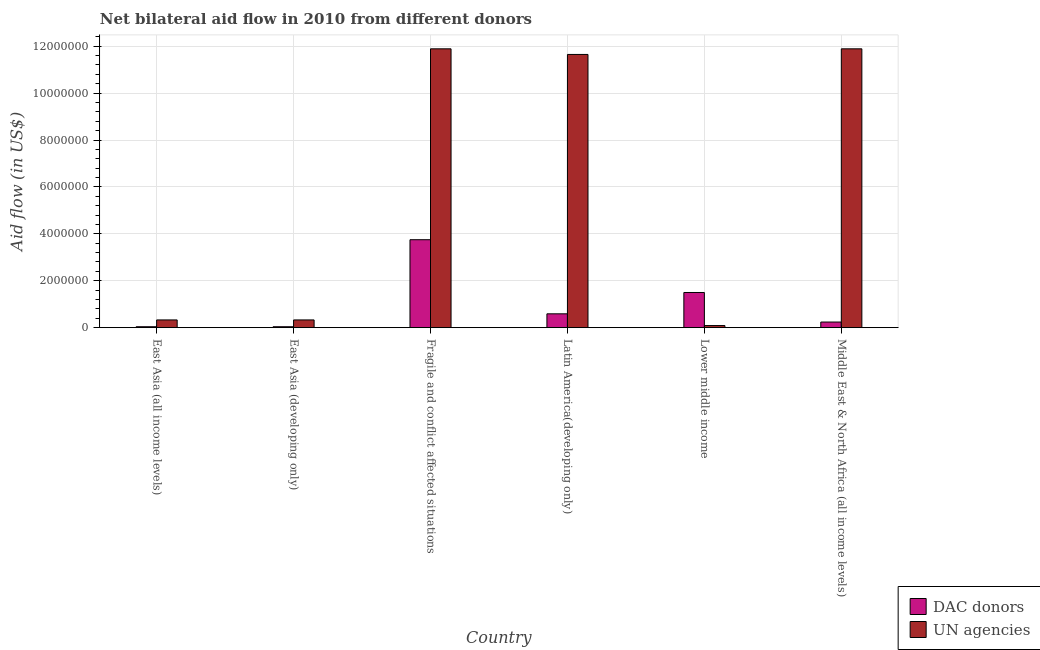Are the number of bars per tick equal to the number of legend labels?
Make the answer very short. Yes. Are the number of bars on each tick of the X-axis equal?
Ensure brevity in your answer.  Yes. What is the label of the 6th group of bars from the left?
Make the answer very short. Middle East & North Africa (all income levels). What is the aid flow from un agencies in Middle East & North Africa (all income levels)?
Your answer should be compact. 1.19e+07. Across all countries, what is the maximum aid flow from un agencies?
Your response must be concise. 1.19e+07. Across all countries, what is the minimum aid flow from dac donors?
Provide a short and direct response. 4.00e+04. In which country was the aid flow from un agencies maximum?
Provide a succinct answer. Fragile and conflict affected situations. In which country was the aid flow from dac donors minimum?
Your answer should be compact. East Asia (all income levels). What is the total aid flow from dac donors in the graph?
Your answer should be very brief. 6.16e+06. What is the difference between the aid flow from dac donors in East Asia (all income levels) and that in Latin America(developing only)?
Offer a very short reply. -5.50e+05. What is the difference between the aid flow from un agencies in Lower middle income and the aid flow from dac donors in East Asia (all income levels)?
Provide a short and direct response. 5.00e+04. What is the average aid flow from dac donors per country?
Your answer should be very brief. 1.03e+06. What is the difference between the aid flow from dac donors and aid flow from un agencies in East Asia (developing only)?
Keep it short and to the point. -2.90e+05. What is the ratio of the aid flow from dac donors in East Asia (developing only) to that in Latin America(developing only)?
Your response must be concise. 0.07. What is the difference between the highest and the second highest aid flow from dac donors?
Give a very brief answer. 2.25e+06. What is the difference between the highest and the lowest aid flow from dac donors?
Offer a very short reply. 3.71e+06. In how many countries, is the aid flow from un agencies greater than the average aid flow from un agencies taken over all countries?
Offer a terse response. 3. Is the sum of the aid flow from dac donors in Latin America(developing only) and Lower middle income greater than the maximum aid flow from un agencies across all countries?
Ensure brevity in your answer.  No. What does the 1st bar from the left in Fragile and conflict affected situations represents?
Keep it short and to the point. DAC donors. What does the 2nd bar from the right in Latin America(developing only) represents?
Offer a terse response. DAC donors. Are all the bars in the graph horizontal?
Offer a very short reply. No. How many countries are there in the graph?
Your response must be concise. 6. Does the graph contain any zero values?
Provide a short and direct response. No. Where does the legend appear in the graph?
Your answer should be compact. Bottom right. How many legend labels are there?
Your answer should be compact. 2. How are the legend labels stacked?
Your response must be concise. Vertical. What is the title of the graph?
Your answer should be very brief. Net bilateral aid flow in 2010 from different donors. What is the label or title of the Y-axis?
Your answer should be compact. Aid flow (in US$). What is the Aid flow (in US$) of DAC donors in Fragile and conflict affected situations?
Make the answer very short. 3.75e+06. What is the Aid flow (in US$) in UN agencies in Fragile and conflict affected situations?
Offer a very short reply. 1.19e+07. What is the Aid flow (in US$) of DAC donors in Latin America(developing only)?
Give a very brief answer. 5.90e+05. What is the Aid flow (in US$) in UN agencies in Latin America(developing only)?
Your answer should be very brief. 1.16e+07. What is the Aid flow (in US$) of DAC donors in Lower middle income?
Your answer should be very brief. 1.50e+06. What is the Aid flow (in US$) of UN agencies in Lower middle income?
Your answer should be compact. 9.00e+04. What is the Aid flow (in US$) of UN agencies in Middle East & North Africa (all income levels)?
Offer a very short reply. 1.19e+07. Across all countries, what is the maximum Aid flow (in US$) in DAC donors?
Give a very brief answer. 3.75e+06. Across all countries, what is the maximum Aid flow (in US$) of UN agencies?
Your answer should be compact. 1.19e+07. Across all countries, what is the minimum Aid flow (in US$) in UN agencies?
Make the answer very short. 9.00e+04. What is the total Aid flow (in US$) of DAC donors in the graph?
Provide a short and direct response. 6.16e+06. What is the total Aid flow (in US$) in UN agencies in the graph?
Offer a terse response. 3.62e+07. What is the difference between the Aid flow (in US$) in DAC donors in East Asia (all income levels) and that in East Asia (developing only)?
Make the answer very short. 0. What is the difference between the Aid flow (in US$) of UN agencies in East Asia (all income levels) and that in East Asia (developing only)?
Offer a terse response. 0. What is the difference between the Aid flow (in US$) of DAC donors in East Asia (all income levels) and that in Fragile and conflict affected situations?
Provide a short and direct response. -3.71e+06. What is the difference between the Aid flow (in US$) of UN agencies in East Asia (all income levels) and that in Fragile and conflict affected situations?
Keep it short and to the point. -1.16e+07. What is the difference between the Aid flow (in US$) in DAC donors in East Asia (all income levels) and that in Latin America(developing only)?
Keep it short and to the point. -5.50e+05. What is the difference between the Aid flow (in US$) of UN agencies in East Asia (all income levels) and that in Latin America(developing only)?
Make the answer very short. -1.13e+07. What is the difference between the Aid flow (in US$) in DAC donors in East Asia (all income levels) and that in Lower middle income?
Provide a succinct answer. -1.46e+06. What is the difference between the Aid flow (in US$) of DAC donors in East Asia (all income levels) and that in Middle East & North Africa (all income levels)?
Offer a terse response. -2.00e+05. What is the difference between the Aid flow (in US$) in UN agencies in East Asia (all income levels) and that in Middle East & North Africa (all income levels)?
Provide a succinct answer. -1.16e+07. What is the difference between the Aid flow (in US$) of DAC donors in East Asia (developing only) and that in Fragile and conflict affected situations?
Keep it short and to the point. -3.71e+06. What is the difference between the Aid flow (in US$) in UN agencies in East Asia (developing only) and that in Fragile and conflict affected situations?
Your response must be concise. -1.16e+07. What is the difference between the Aid flow (in US$) of DAC donors in East Asia (developing only) and that in Latin America(developing only)?
Make the answer very short. -5.50e+05. What is the difference between the Aid flow (in US$) in UN agencies in East Asia (developing only) and that in Latin America(developing only)?
Make the answer very short. -1.13e+07. What is the difference between the Aid flow (in US$) in DAC donors in East Asia (developing only) and that in Lower middle income?
Your response must be concise. -1.46e+06. What is the difference between the Aid flow (in US$) of UN agencies in East Asia (developing only) and that in Middle East & North Africa (all income levels)?
Provide a succinct answer. -1.16e+07. What is the difference between the Aid flow (in US$) of DAC donors in Fragile and conflict affected situations and that in Latin America(developing only)?
Keep it short and to the point. 3.16e+06. What is the difference between the Aid flow (in US$) in DAC donors in Fragile and conflict affected situations and that in Lower middle income?
Offer a terse response. 2.25e+06. What is the difference between the Aid flow (in US$) of UN agencies in Fragile and conflict affected situations and that in Lower middle income?
Make the answer very short. 1.18e+07. What is the difference between the Aid flow (in US$) of DAC donors in Fragile and conflict affected situations and that in Middle East & North Africa (all income levels)?
Your answer should be compact. 3.51e+06. What is the difference between the Aid flow (in US$) of UN agencies in Fragile and conflict affected situations and that in Middle East & North Africa (all income levels)?
Ensure brevity in your answer.  0. What is the difference between the Aid flow (in US$) in DAC donors in Latin America(developing only) and that in Lower middle income?
Provide a short and direct response. -9.10e+05. What is the difference between the Aid flow (in US$) in UN agencies in Latin America(developing only) and that in Lower middle income?
Make the answer very short. 1.16e+07. What is the difference between the Aid flow (in US$) in DAC donors in Lower middle income and that in Middle East & North Africa (all income levels)?
Keep it short and to the point. 1.26e+06. What is the difference between the Aid flow (in US$) in UN agencies in Lower middle income and that in Middle East & North Africa (all income levels)?
Give a very brief answer. -1.18e+07. What is the difference between the Aid flow (in US$) of DAC donors in East Asia (all income levels) and the Aid flow (in US$) of UN agencies in Fragile and conflict affected situations?
Make the answer very short. -1.18e+07. What is the difference between the Aid flow (in US$) of DAC donors in East Asia (all income levels) and the Aid flow (in US$) of UN agencies in Latin America(developing only)?
Offer a terse response. -1.16e+07. What is the difference between the Aid flow (in US$) of DAC donors in East Asia (all income levels) and the Aid flow (in US$) of UN agencies in Middle East & North Africa (all income levels)?
Provide a succinct answer. -1.18e+07. What is the difference between the Aid flow (in US$) of DAC donors in East Asia (developing only) and the Aid flow (in US$) of UN agencies in Fragile and conflict affected situations?
Provide a short and direct response. -1.18e+07. What is the difference between the Aid flow (in US$) in DAC donors in East Asia (developing only) and the Aid flow (in US$) in UN agencies in Latin America(developing only)?
Provide a succinct answer. -1.16e+07. What is the difference between the Aid flow (in US$) in DAC donors in East Asia (developing only) and the Aid flow (in US$) in UN agencies in Middle East & North Africa (all income levels)?
Your answer should be very brief. -1.18e+07. What is the difference between the Aid flow (in US$) in DAC donors in Fragile and conflict affected situations and the Aid flow (in US$) in UN agencies in Latin America(developing only)?
Your response must be concise. -7.90e+06. What is the difference between the Aid flow (in US$) in DAC donors in Fragile and conflict affected situations and the Aid flow (in US$) in UN agencies in Lower middle income?
Ensure brevity in your answer.  3.66e+06. What is the difference between the Aid flow (in US$) in DAC donors in Fragile and conflict affected situations and the Aid flow (in US$) in UN agencies in Middle East & North Africa (all income levels)?
Keep it short and to the point. -8.14e+06. What is the difference between the Aid flow (in US$) in DAC donors in Latin America(developing only) and the Aid flow (in US$) in UN agencies in Middle East & North Africa (all income levels)?
Give a very brief answer. -1.13e+07. What is the difference between the Aid flow (in US$) of DAC donors in Lower middle income and the Aid flow (in US$) of UN agencies in Middle East & North Africa (all income levels)?
Ensure brevity in your answer.  -1.04e+07. What is the average Aid flow (in US$) of DAC donors per country?
Give a very brief answer. 1.03e+06. What is the average Aid flow (in US$) of UN agencies per country?
Provide a short and direct response. 6.03e+06. What is the difference between the Aid flow (in US$) of DAC donors and Aid flow (in US$) of UN agencies in East Asia (all income levels)?
Offer a terse response. -2.90e+05. What is the difference between the Aid flow (in US$) of DAC donors and Aid flow (in US$) of UN agencies in East Asia (developing only)?
Your answer should be compact. -2.90e+05. What is the difference between the Aid flow (in US$) of DAC donors and Aid flow (in US$) of UN agencies in Fragile and conflict affected situations?
Your answer should be very brief. -8.14e+06. What is the difference between the Aid flow (in US$) of DAC donors and Aid flow (in US$) of UN agencies in Latin America(developing only)?
Your response must be concise. -1.11e+07. What is the difference between the Aid flow (in US$) in DAC donors and Aid flow (in US$) in UN agencies in Lower middle income?
Offer a very short reply. 1.41e+06. What is the difference between the Aid flow (in US$) in DAC donors and Aid flow (in US$) in UN agencies in Middle East & North Africa (all income levels)?
Provide a succinct answer. -1.16e+07. What is the ratio of the Aid flow (in US$) in DAC donors in East Asia (all income levels) to that in East Asia (developing only)?
Your answer should be compact. 1. What is the ratio of the Aid flow (in US$) of UN agencies in East Asia (all income levels) to that in East Asia (developing only)?
Offer a very short reply. 1. What is the ratio of the Aid flow (in US$) of DAC donors in East Asia (all income levels) to that in Fragile and conflict affected situations?
Make the answer very short. 0.01. What is the ratio of the Aid flow (in US$) in UN agencies in East Asia (all income levels) to that in Fragile and conflict affected situations?
Offer a very short reply. 0.03. What is the ratio of the Aid flow (in US$) in DAC donors in East Asia (all income levels) to that in Latin America(developing only)?
Offer a very short reply. 0.07. What is the ratio of the Aid flow (in US$) of UN agencies in East Asia (all income levels) to that in Latin America(developing only)?
Ensure brevity in your answer.  0.03. What is the ratio of the Aid flow (in US$) of DAC donors in East Asia (all income levels) to that in Lower middle income?
Your response must be concise. 0.03. What is the ratio of the Aid flow (in US$) of UN agencies in East Asia (all income levels) to that in Lower middle income?
Keep it short and to the point. 3.67. What is the ratio of the Aid flow (in US$) of UN agencies in East Asia (all income levels) to that in Middle East & North Africa (all income levels)?
Offer a terse response. 0.03. What is the ratio of the Aid flow (in US$) in DAC donors in East Asia (developing only) to that in Fragile and conflict affected situations?
Provide a short and direct response. 0.01. What is the ratio of the Aid flow (in US$) of UN agencies in East Asia (developing only) to that in Fragile and conflict affected situations?
Ensure brevity in your answer.  0.03. What is the ratio of the Aid flow (in US$) of DAC donors in East Asia (developing only) to that in Latin America(developing only)?
Ensure brevity in your answer.  0.07. What is the ratio of the Aid flow (in US$) in UN agencies in East Asia (developing only) to that in Latin America(developing only)?
Provide a succinct answer. 0.03. What is the ratio of the Aid flow (in US$) in DAC donors in East Asia (developing only) to that in Lower middle income?
Offer a very short reply. 0.03. What is the ratio of the Aid flow (in US$) in UN agencies in East Asia (developing only) to that in Lower middle income?
Keep it short and to the point. 3.67. What is the ratio of the Aid flow (in US$) of UN agencies in East Asia (developing only) to that in Middle East & North Africa (all income levels)?
Provide a succinct answer. 0.03. What is the ratio of the Aid flow (in US$) in DAC donors in Fragile and conflict affected situations to that in Latin America(developing only)?
Your answer should be compact. 6.36. What is the ratio of the Aid flow (in US$) in UN agencies in Fragile and conflict affected situations to that in Latin America(developing only)?
Provide a short and direct response. 1.02. What is the ratio of the Aid flow (in US$) of UN agencies in Fragile and conflict affected situations to that in Lower middle income?
Ensure brevity in your answer.  132.11. What is the ratio of the Aid flow (in US$) of DAC donors in Fragile and conflict affected situations to that in Middle East & North Africa (all income levels)?
Make the answer very short. 15.62. What is the ratio of the Aid flow (in US$) of DAC donors in Latin America(developing only) to that in Lower middle income?
Give a very brief answer. 0.39. What is the ratio of the Aid flow (in US$) of UN agencies in Latin America(developing only) to that in Lower middle income?
Ensure brevity in your answer.  129.44. What is the ratio of the Aid flow (in US$) of DAC donors in Latin America(developing only) to that in Middle East & North Africa (all income levels)?
Provide a short and direct response. 2.46. What is the ratio of the Aid flow (in US$) in UN agencies in Latin America(developing only) to that in Middle East & North Africa (all income levels)?
Offer a very short reply. 0.98. What is the ratio of the Aid flow (in US$) in DAC donors in Lower middle income to that in Middle East & North Africa (all income levels)?
Provide a succinct answer. 6.25. What is the ratio of the Aid flow (in US$) in UN agencies in Lower middle income to that in Middle East & North Africa (all income levels)?
Make the answer very short. 0.01. What is the difference between the highest and the second highest Aid flow (in US$) in DAC donors?
Make the answer very short. 2.25e+06. What is the difference between the highest and the second highest Aid flow (in US$) in UN agencies?
Your answer should be very brief. 0. What is the difference between the highest and the lowest Aid flow (in US$) of DAC donors?
Your answer should be very brief. 3.71e+06. What is the difference between the highest and the lowest Aid flow (in US$) in UN agencies?
Your answer should be very brief. 1.18e+07. 